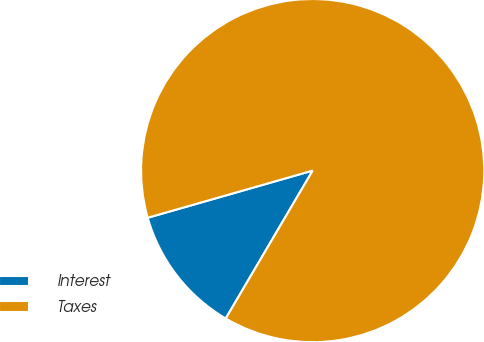<chart> <loc_0><loc_0><loc_500><loc_500><pie_chart><fcel>Interest<fcel>Taxes<nl><fcel>12.11%<fcel>87.89%<nl></chart> 